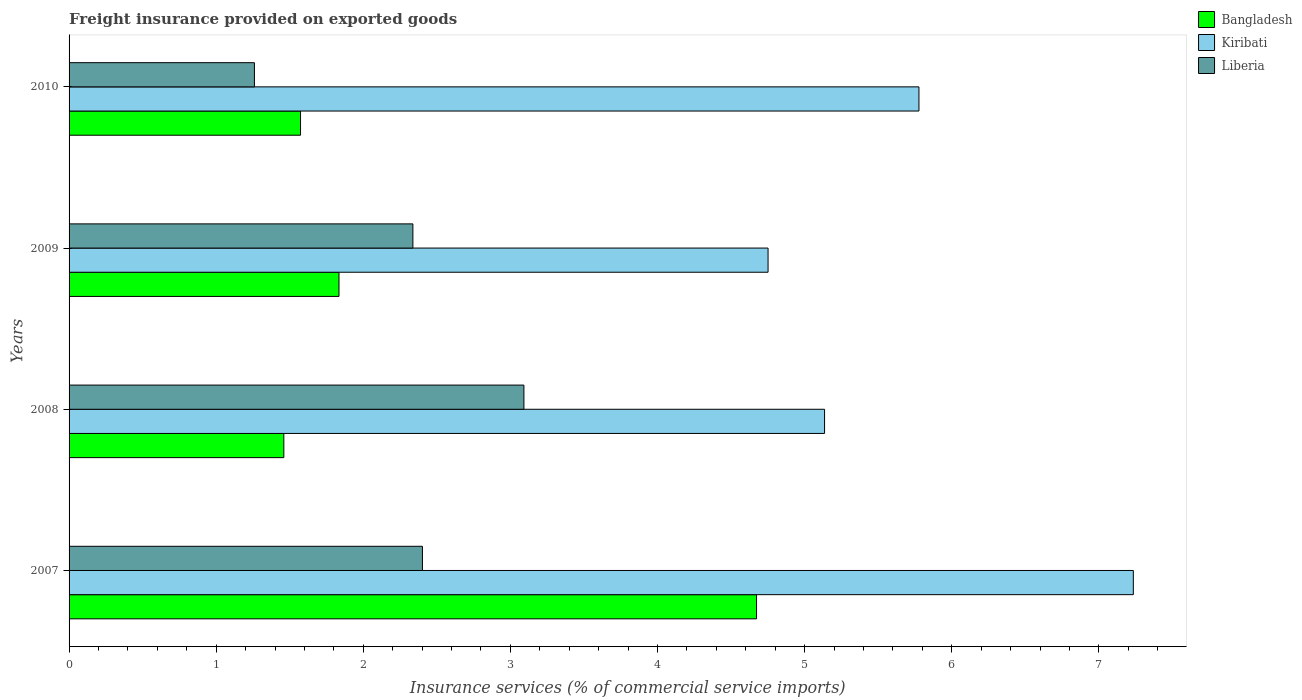How many different coloured bars are there?
Offer a very short reply. 3. How many groups of bars are there?
Make the answer very short. 4. Are the number of bars per tick equal to the number of legend labels?
Your answer should be compact. Yes. Are the number of bars on each tick of the Y-axis equal?
Give a very brief answer. Yes. How many bars are there on the 1st tick from the top?
Your answer should be very brief. 3. How many bars are there on the 4th tick from the bottom?
Your answer should be very brief. 3. What is the label of the 1st group of bars from the top?
Offer a very short reply. 2010. In how many cases, is the number of bars for a given year not equal to the number of legend labels?
Provide a succinct answer. 0. What is the freight insurance provided on exported goods in Kiribati in 2009?
Offer a terse response. 4.75. Across all years, what is the maximum freight insurance provided on exported goods in Kiribati?
Offer a terse response. 7.23. Across all years, what is the minimum freight insurance provided on exported goods in Kiribati?
Your response must be concise. 4.75. What is the total freight insurance provided on exported goods in Liberia in the graph?
Ensure brevity in your answer.  9.09. What is the difference between the freight insurance provided on exported goods in Liberia in 2008 and that in 2009?
Provide a succinct answer. 0.75. What is the difference between the freight insurance provided on exported goods in Liberia in 2010 and the freight insurance provided on exported goods in Kiribati in 2007?
Your answer should be compact. -5.97. What is the average freight insurance provided on exported goods in Kiribati per year?
Keep it short and to the point. 5.72. In the year 2010, what is the difference between the freight insurance provided on exported goods in Kiribati and freight insurance provided on exported goods in Bangladesh?
Your answer should be compact. 4.2. What is the ratio of the freight insurance provided on exported goods in Liberia in 2007 to that in 2009?
Your response must be concise. 1.03. What is the difference between the highest and the second highest freight insurance provided on exported goods in Kiribati?
Offer a very short reply. 1.46. What is the difference between the highest and the lowest freight insurance provided on exported goods in Bangladesh?
Give a very brief answer. 3.21. In how many years, is the freight insurance provided on exported goods in Liberia greater than the average freight insurance provided on exported goods in Liberia taken over all years?
Provide a succinct answer. 3. What does the 1st bar from the top in 2007 represents?
Your answer should be compact. Liberia. What does the 3rd bar from the bottom in 2010 represents?
Provide a succinct answer. Liberia. Is it the case that in every year, the sum of the freight insurance provided on exported goods in Kiribati and freight insurance provided on exported goods in Liberia is greater than the freight insurance provided on exported goods in Bangladesh?
Provide a short and direct response. Yes. How many bars are there?
Offer a terse response. 12. How many years are there in the graph?
Your answer should be very brief. 4. What is the difference between two consecutive major ticks on the X-axis?
Your answer should be very brief. 1. Are the values on the major ticks of X-axis written in scientific E-notation?
Provide a succinct answer. No. What is the title of the graph?
Your answer should be compact. Freight insurance provided on exported goods. What is the label or title of the X-axis?
Your answer should be very brief. Insurance services (% of commercial service imports). What is the Insurance services (% of commercial service imports) in Bangladesh in 2007?
Your response must be concise. 4.67. What is the Insurance services (% of commercial service imports) of Kiribati in 2007?
Make the answer very short. 7.23. What is the Insurance services (% of commercial service imports) in Liberia in 2007?
Give a very brief answer. 2.4. What is the Insurance services (% of commercial service imports) in Bangladesh in 2008?
Make the answer very short. 1.46. What is the Insurance services (% of commercial service imports) in Kiribati in 2008?
Give a very brief answer. 5.14. What is the Insurance services (% of commercial service imports) of Liberia in 2008?
Your answer should be very brief. 3.09. What is the Insurance services (% of commercial service imports) in Bangladesh in 2009?
Give a very brief answer. 1.83. What is the Insurance services (% of commercial service imports) in Kiribati in 2009?
Offer a terse response. 4.75. What is the Insurance services (% of commercial service imports) in Liberia in 2009?
Your response must be concise. 2.34. What is the Insurance services (% of commercial service imports) of Bangladesh in 2010?
Offer a very short reply. 1.57. What is the Insurance services (% of commercial service imports) of Kiribati in 2010?
Provide a short and direct response. 5.78. What is the Insurance services (% of commercial service imports) in Liberia in 2010?
Offer a terse response. 1.26. Across all years, what is the maximum Insurance services (% of commercial service imports) of Bangladesh?
Your answer should be compact. 4.67. Across all years, what is the maximum Insurance services (% of commercial service imports) in Kiribati?
Make the answer very short. 7.23. Across all years, what is the maximum Insurance services (% of commercial service imports) of Liberia?
Your response must be concise. 3.09. Across all years, what is the minimum Insurance services (% of commercial service imports) in Bangladesh?
Provide a short and direct response. 1.46. Across all years, what is the minimum Insurance services (% of commercial service imports) of Kiribati?
Provide a succinct answer. 4.75. Across all years, what is the minimum Insurance services (% of commercial service imports) in Liberia?
Give a very brief answer. 1.26. What is the total Insurance services (% of commercial service imports) in Bangladesh in the graph?
Keep it short and to the point. 9.54. What is the total Insurance services (% of commercial service imports) in Kiribati in the graph?
Provide a succinct answer. 22.9. What is the total Insurance services (% of commercial service imports) of Liberia in the graph?
Your response must be concise. 9.09. What is the difference between the Insurance services (% of commercial service imports) in Bangladesh in 2007 and that in 2008?
Offer a very short reply. 3.21. What is the difference between the Insurance services (% of commercial service imports) in Kiribati in 2007 and that in 2008?
Keep it short and to the point. 2.1. What is the difference between the Insurance services (% of commercial service imports) in Liberia in 2007 and that in 2008?
Offer a very short reply. -0.69. What is the difference between the Insurance services (% of commercial service imports) of Bangladesh in 2007 and that in 2009?
Your answer should be very brief. 2.84. What is the difference between the Insurance services (% of commercial service imports) in Kiribati in 2007 and that in 2009?
Provide a short and direct response. 2.48. What is the difference between the Insurance services (% of commercial service imports) of Liberia in 2007 and that in 2009?
Your response must be concise. 0.06. What is the difference between the Insurance services (% of commercial service imports) in Bangladesh in 2007 and that in 2010?
Offer a very short reply. 3.1. What is the difference between the Insurance services (% of commercial service imports) in Kiribati in 2007 and that in 2010?
Provide a short and direct response. 1.46. What is the difference between the Insurance services (% of commercial service imports) of Liberia in 2007 and that in 2010?
Provide a succinct answer. 1.14. What is the difference between the Insurance services (% of commercial service imports) of Bangladesh in 2008 and that in 2009?
Provide a short and direct response. -0.37. What is the difference between the Insurance services (% of commercial service imports) of Kiribati in 2008 and that in 2009?
Offer a very short reply. 0.38. What is the difference between the Insurance services (% of commercial service imports) in Liberia in 2008 and that in 2009?
Make the answer very short. 0.75. What is the difference between the Insurance services (% of commercial service imports) in Bangladesh in 2008 and that in 2010?
Your response must be concise. -0.11. What is the difference between the Insurance services (% of commercial service imports) of Kiribati in 2008 and that in 2010?
Offer a terse response. -0.64. What is the difference between the Insurance services (% of commercial service imports) of Liberia in 2008 and that in 2010?
Ensure brevity in your answer.  1.83. What is the difference between the Insurance services (% of commercial service imports) of Bangladesh in 2009 and that in 2010?
Keep it short and to the point. 0.26. What is the difference between the Insurance services (% of commercial service imports) of Kiribati in 2009 and that in 2010?
Keep it short and to the point. -1.03. What is the difference between the Insurance services (% of commercial service imports) in Liberia in 2009 and that in 2010?
Offer a very short reply. 1.08. What is the difference between the Insurance services (% of commercial service imports) of Bangladesh in 2007 and the Insurance services (% of commercial service imports) of Kiribati in 2008?
Your answer should be very brief. -0.46. What is the difference between the Insurance services (% of commercial service imports) in Bangladesh in 2007 and the Insurance services (% of commercial service imports) in Liberia in 2008?
Your response must be concise. 1.58. What is the difference between the Insurance services (% of commercial service imports) of Kiribati in 2007 and the Insurance services (% of commercial service imports) of Liberia in 2008?
Ensure brevity in your answer.  4.14. What is the difference between the Insurance services (% of commercial service imports) in Bangladesh in 2007 and the Insurance services (% of commercial service imports) in Kiribati in 2009?
Ensure brevity in your answer.  -0.08. What is the difference between the Insurance services (% of commercial service imports) of Bangladesh in 2007 and the Insurance services (% of commercial service imports) of Liberia in 2009?
Your response must be concise. 2.34. What is the difference between the Insurance services (% of commercial service imports) in Kiribati in 2007 and the Insurance services (% of commercial service imports) in Liberia in 2009?
Keep it short and to the point. 4.9. What is the difference between the Insurance services (% of commercial service imports) in Bangladesh in 2007 and the Insurance services (% of commercial service imports) in Kiribati in 2010?
Offer a very short reply. -1.1. What is the difference between the Insurance services (% of commercial service imports) of Bangladesh in 2007 and the Insurance services (% of commercial service imports) of Liberia in 2010?
Offer a terse response. 3.41. What is the difference between the Insurance services (% of commercial service imports) of Kiribati in 2007 and the Insurance services (% of commercial service imports) of Liberia in 2010?
Your answer should be very brief. 5.97. What is the difference between the Insurance services (% of commercial service imports) in Bangladesh in 2008 and the Insurance services (% of commercial service imports) in Kiribati in 2009?
Offer a terse response. -3.29. What is the difference between the Insurance services (% of commercial service imports) in Bangladesh in 2008 and the Insurance services (% of commercial service imports) in Liberia in 2009?
Offer a terse response. -0.88. What is the difference between the Insurance services (% of commercial service imports) in Kiribati in 2008 and the Insurance services (% of commercial service imports) in Liberia in 2009?
Make the answer very short. 2.8. What is the difference between the Insurance services (% of commercial service imports) in Bangladesh in 2008 and the Insurance services (% of commercial service imports) in Kiribati in 2010?
Offer a very short reply. -4.32. What is the difference between the Insurance services (% of commercial service imports) of Bangladesh in 2008 and the Insurance services (% of commercial service imports) of Liberia in 2010?
Provide a succinct answer. 0.2. What is the difference between the Insurance services (% of commercial service imports) of Kiribati in 2008 and the Insurance services (% of commercial service imports) of Liberia in 2010?
Make the answer very short. 3.88. What is the difference between the Insurance services (% of commercial service imports) of Bangladesh in 2009 and the Insurance services (% of commercial service imports) of Kiribati in 2010?
Offer a very short reply. -3.94. What is the difference between the Insurance services (% of commercial service imports) of Bangladesh in 2009 and the Insurance services (% of commercial service imports) of Liberia in 2010?
Provide a succinct answer. 0.57. What is the difference between the Insurance services (% of commercial service imports) of Kiribati in 2009 and the Insurance services (% of commercial service imports) of Liberia in 2010?
Make the answer very short. 3.49. What is the average Insurance services (% of commercial service imports) of Bangladesh per year?
Give a very brief answer. 2.39. What is the average Insurance services (% of commercial service imports) of Kiribati per year?
Provide a short and direct response. 5.72. What is the average Insurance services (% of commercial service imports) in Liberia per year?
Ensure brevity in your answer.  2.27. In the year 2007, what is the difference between the Insurance services (% of commercial service imports) of Bangladesh and Insurance services (% of commercial service imports) of Kiribati?
Give a very brief answer. -2.56. In the year 2007, what is the difference between the Insurance services (% of commercial service imports) in Bangladesh and Insurance services (% of commercial service imports) in Liberia?
Offer a terse response. 2.27. In the year 2007, what is the difference between the Insurance services (% of commercial service imports) of Kiribati and Insurance services (% of commercial service imports) of Liberia?
Give a very brief answer. 4.83. In the year 2008, what is the difference between the Insurance services (% of commercial service imports) in Bangladesh and Insurance services (% of commercial service imports) in Kiribati?
Your answer should be compact. -3.68. In the year 2008, what is the difference between the Insurance services (% of commercial service imports) of Bangladesh and Insurance services (% of commercial service imports) of Liberia?
Offer a very short reply. -1.63. In the year 2008, what is the difference between the Insurance services (% of commercial service imports) in Kiribati and Insurance services (% of commercial service imports) in Liberia?
Your answer should be very brief. 2.04. In the year 2009, what is the difference between the Insurance services (% of commercial service imports) of Bangladesh and Insurance services (% of commercial service imports) of Kiribati?
Keep it short and to the point. -2.92. In the year 2009, what is the difference between the Insurance services (% of commercial service imports) in Bangladesh and Insurance services (% of commercial service imports) in Liberia?
Your response must be concise. -0.5. In the year 2009, what is the difference between the Insurance services (% of commercial service imports) in Kiribati and Insurance services (% of commercial service imports) in Liberia?
Your answer should be very brief. 2.41. In the year 2010, what is the difference between the Insurance services (% of commercial service imports) of Bangladesh and Insurance services (% of commercial service imports) of Kiribati?
Provide a succinct answer. -4.2. In the year 2010, what is the difference between the Insurance services (% of commercial service imports) in Bangladesh and Insurance services (% of commercial service imports) in Liberia?
Make the answer very short. 0.31. In the year 2010, what is the difference between the Insurance services (% of commercial service imports) in Kiribati and Insurance services (% of commercial service imports) in Liberia?
Your answer should be compact. 4.52. What is the ratio of the Insurance services (% of commercial service imports) of Bangladesh in 2007 to that in 2008?
Offer a very short reply. 3.2. What is the ratio of the Insurance services (% of commercial service imports) of Kiribati in 2007 to that in 2008?
Ensure brevity in your answer.  1.41. What is the ratio of the Insurance services (% of commercial service imports) in Liberia in 2007 to that in 2008?
Ensure brevity in your answer.  0.78. What is the ratio of the Insurance services (% of commercial service imports) of Bangladesh in 2007 to that in 2009?
Ensure brevity in your answer.  2.55. What is the ratio of the Insurance services (% of commercial service imports) in Kiribati in 2007 to that in 2009?
Your response must be concise. 1.52. What is the ratio of the Insurance services (% of commercial service imports) of Liberia in 2007 to that in 2009?
Ensure brevity in your answer.  1.03. What is the ratio of the Insurance services (% of commercial service imports) in Bangladesh in 2007 to that in 2010?
Your answer should be very brief. 2.97. What is the ratio of the Insurance services (% of commercial service imports) of Kiribati in 2007 to that in 2010?
Provide a succinct answer. 1.25. What is the ratio of the Insurance services (% of commercial service imports) of Liberia in 2007 to that in 2010?
Your response must be concise. 1.91. What is the ratio of the Insurance services (% of commercial service imports) of Bangladesh in 2008 to that in 2009?
Your response must be concise. 0.8. What is the ratio of the Insurance services (% of commercial service imports) of Kiribati in 2008 to that in 2009?
Offer a very short reply. 1.08. What is the ratio of the Insurance services (% of commercial service imports) of Liberia in 2008 to that in 2009?
Provide a short and direct response. 1.32. What is the ratio of the Insurance services (% of commercial service imports) in Bangladesh in 2008 to that in 2010?
Provide a succinct answer. 0.93. What is the ratio of the Insurance services (% of commercial service imports) in Kiribati in 2008 to that in 2010?
Keep it short and to the point. 0.89. What is the ratio of the Insurance services (% of commercial service imports) of Liberia in 2008 to that in 2010?
Give a very brief answer. 2.45. What is the ratio of the Insurance services (% of commercial service imports) of Bangladesh in 2009 to that in 2010?
Give a very brief answer. 1.17. What is the ratio of the Insurance services (% of commercial service imports) in Kiribati in 2009 to that in 2010?
Offer a terse response. 0.82. What is the ratio of the Insurance services (% of commercial service imports) in Liberia in 2009 to that in 2010?
Make the answer very short. 1.85. What is the difference between the highest and the second highest Insurance services (% of commercial service imports) of Bangladesh?
Your response must be concise. 2.84. What is the difference between the highest and the second highest Insurance services (% of commercial service imports) in Kiribati?
Give a very brief answer. 1.46. What is the difference between the highest and the second highest Insurance services (% of commercial service imports) in Liberia?
Your answer should be very brief. 0.69. What is the difference between the highest and the lowest Insurance services (% of commercial service imports) in Bangladesh?
Your answer should be compact. 3.21. What is the difference between the highest and the lowest Insurance services (% of commercial service imports) of Kiribati?
Provide a short and direct response. 2.48. What is the difference between the highest and the lowest Insurance services (% of commercial service imports) in Liberia?
Your answer should be very brief. 1.83. 